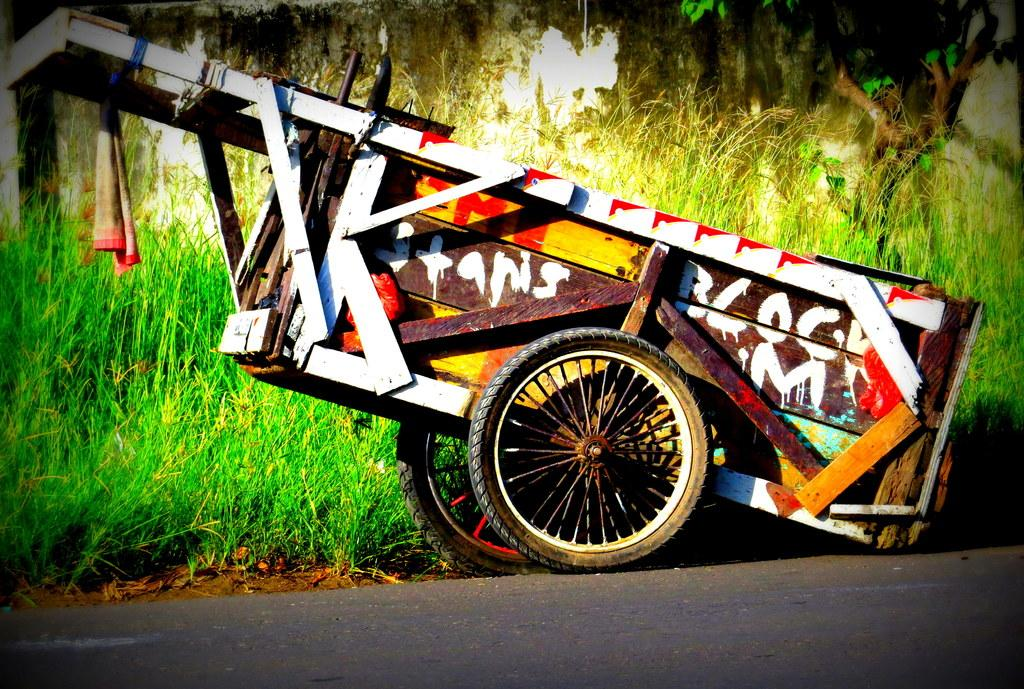What is the main subject in the center of the image? There is a vehicle in the center of the image. What can be seen on the vehicle? The vehicle has painting and text on it. What is visible at the bottom of the image? There is a road at the bottom of the image. What type of vegetation is visible in the background of the image? There are trees and grass in the background of the image. Can you hear the quiet verse being recited by the trees in the background of the image? There is no sound or verse present in the image; it is a visual representation of a vehicle, road, and background vegetation. 